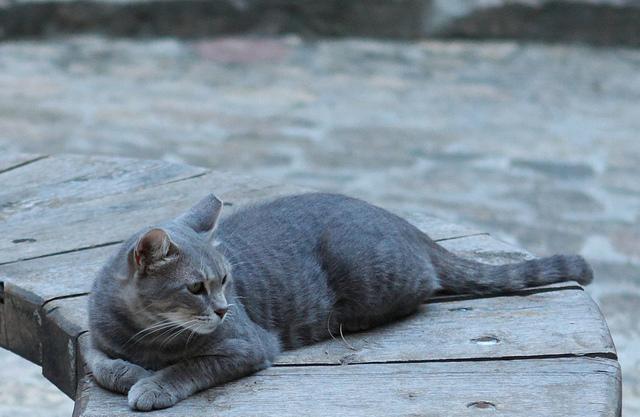Did the cat catch a mouse?
Quick response, please. No. What is in the picture?
Keep it brief. Cat. What color is the cat?
Keep it brief. Gray. 